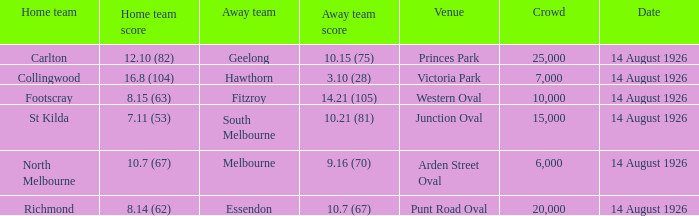What was the crowd size at Victoria Park? 7000.0. 